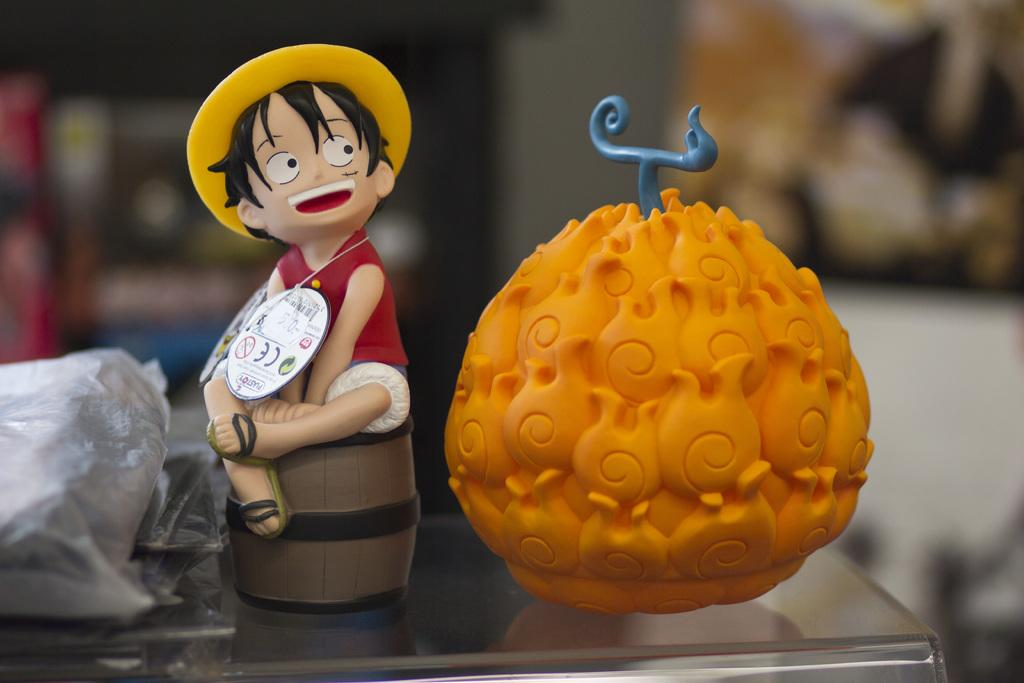What objects are on the glass surface in the image? There are toys on the glass surface. Is there any additional covering on the glass surface? Yes, there is a plastic cover on the glass surface. How many frogs can be seen hopping on the toys in the image? There are no frogs present in the image. What type of prose is being recited by the toys in the image? The toys in the image are not reciting any prose, as they are inanimate objects. 